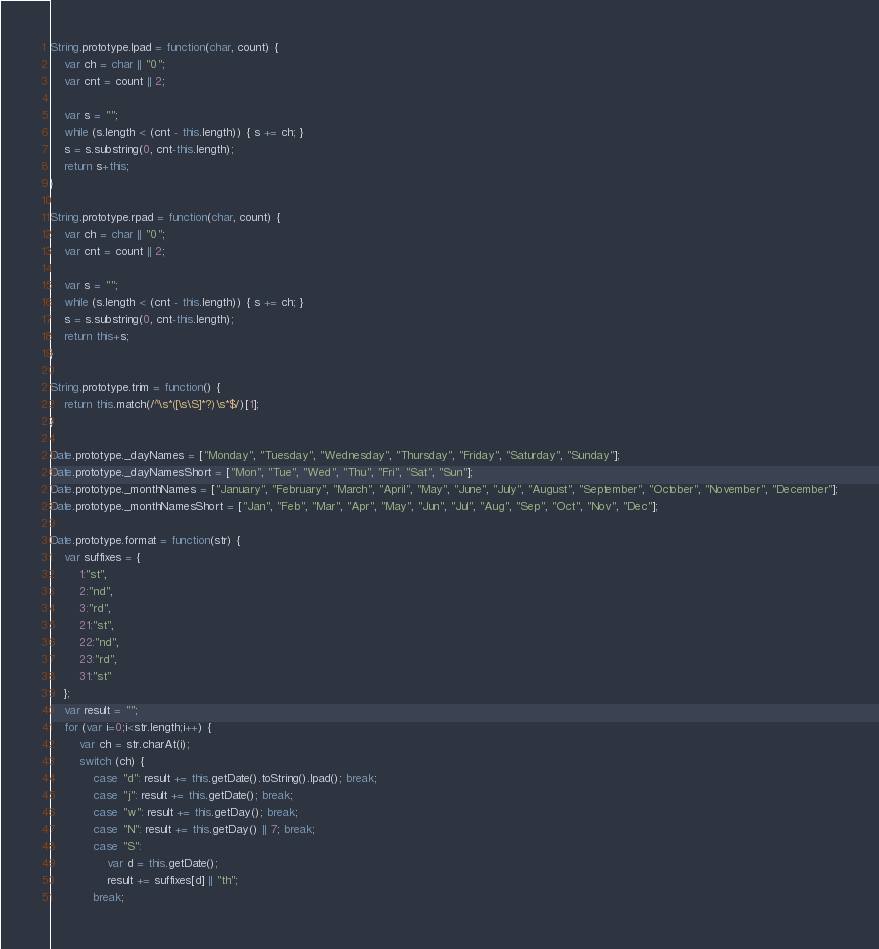<code> <loc_0><loc_0><loc_500><loc_500><_JavaScript_>String.prototype.lpad = function(char, count) {
	var ch = char || "0";
	var cnt = count || 2;

	var s = "";
	while (s.length < (cnt - this.length)) { s += ch; }
	s = s.substring(0, cnt-this.length);
	return s+this;
}

String.prototype.rpad = function(char, count) {
	var ch = char || "0";
	var cnt = count || 2;

	var s = "";
	while (s.length < (cnt - this.length)) { s += ch; }
	s = s.substring(0, cnt-this.length);
	return this+s;
}

String.prototype.trim = function() {
	return this.match(/^\s*([\s\S]*?)\s*$/)[1];
}

Date.prototype._dayNames = ["Monday", "Tuesday", "Wednesday", "Thursday", "Friday", "Saturday", "Sunday"];
Date.prototype._dayNamesShort = ["Mon", "Tue", "Wed", "Thu", "Fri", "Sat", "Sun"];
Date.prototype._monthNames = ["January", "February", "March", "April", "May", "June", "July", "August", "September", "October", "November", "December"];
Date.prototype._monthNamesShort = ["Jan", "Feb", "Mar", "Apr", "May", "Jun", "Jul", "Aug", "Sep", "Oct", "Nov", "Dec"];

Date.prototype.format = function(str) {
	var suffixes = {
		1:"st",
		2:"nd",
		3:"rd",
		21:"st",
		22:"nd",
		23:"rd",
		31:"st"
	};
	var result = "";
	for (var i=0;i<str.length;i++) {
		var ch = str.charAt(i);
		switch (ch) {
			case "d": result += this.getDate().toString().lpad(); break;
			case "j": result += this.getDate(); break;
			case "w": result += this.getDay(); break;
			case "N": result += this.getDay() || 7; break;
			case "S": 
				var d = this.getDate();
				result += suffixes[d] || "th";
			break;</code> 